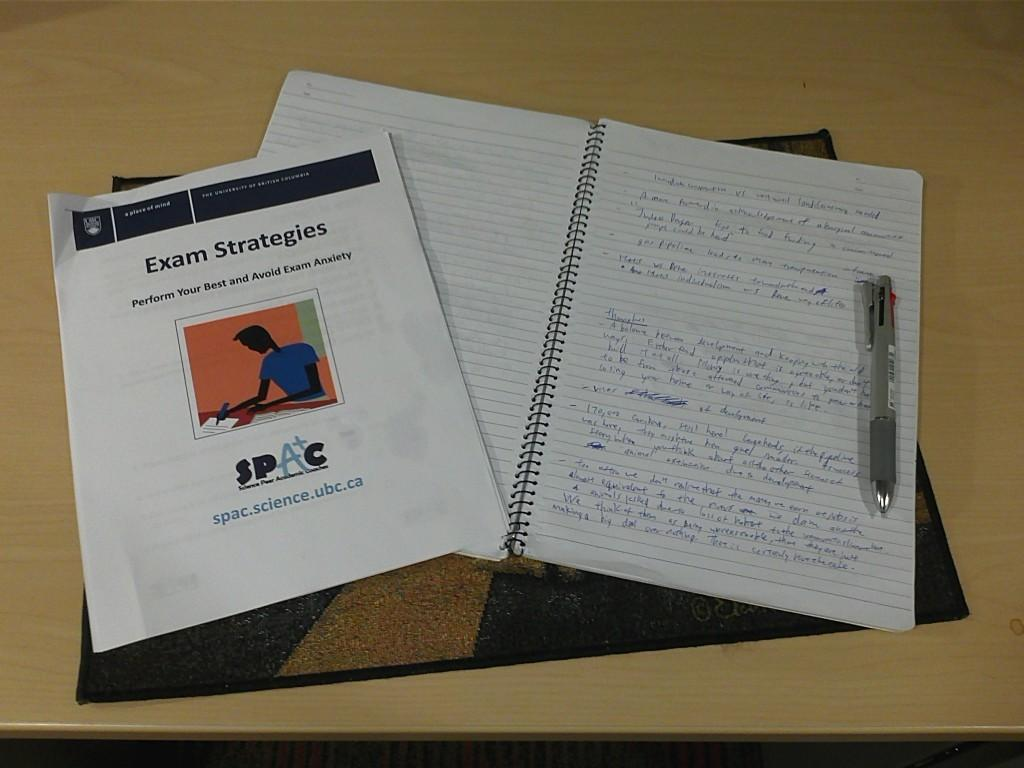<image>
Summarize the visual content of the image. Handwritten notes on a notepad with a printout pamphlet of Exam Strategies 